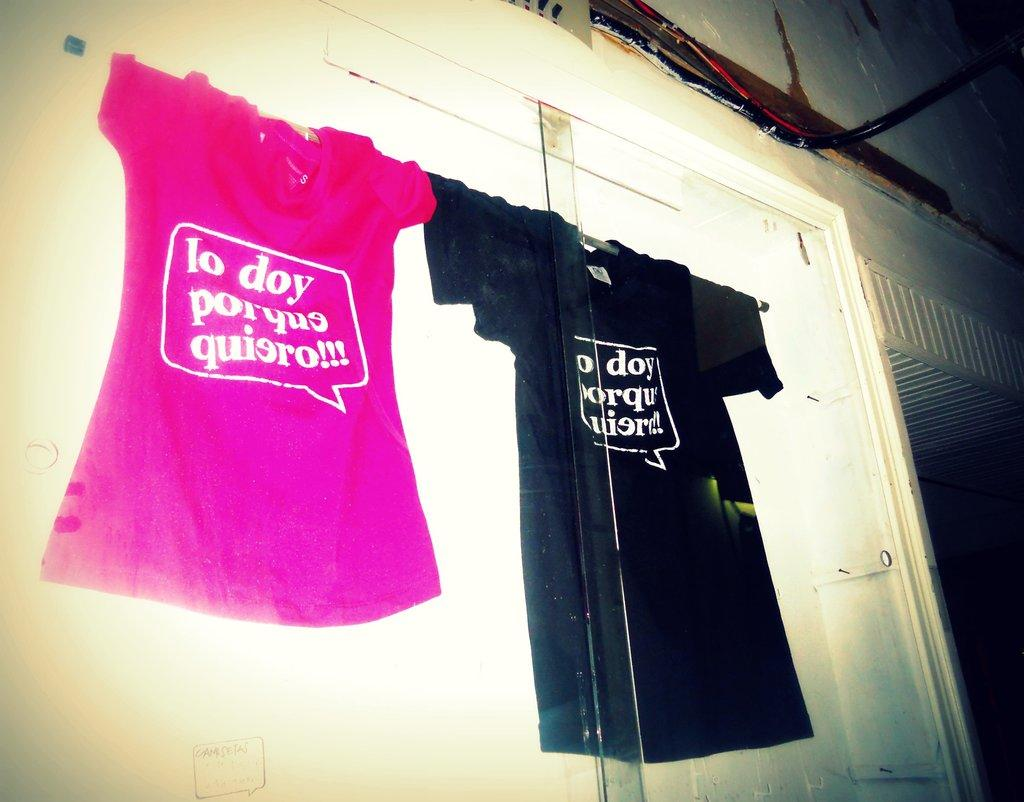<image>
Give a short and clear explanation of the subsequent image. display with pink shirt and black shirt  with lo doy porque quiero!!! on them 